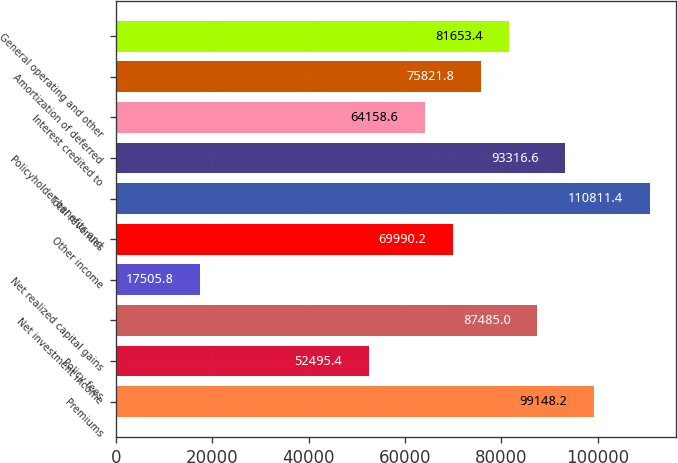Convert chart to OTSL. <chart><loc_0><loc_0><loc_500><loc_500><bar_chart><fcel>Premiums<fcel>Policy fees<fcel>Net investment income<fcel>Net realized capital gains<fcel>Other income<fcel>Total revenues<fcel>Policyholder benefits and<fcel>Interest credited to<fcel>Amortization of deferred<fcel>General operating and other<nl><fcel>99148.2<fcel>52495.4<fcel>87485<fcel>17505.8<fcel>69990.2<fcel>110811<fcel>93316.6<fcel>64158.6<fcel>75821.8<fcel>81653.4<nl></chart> 